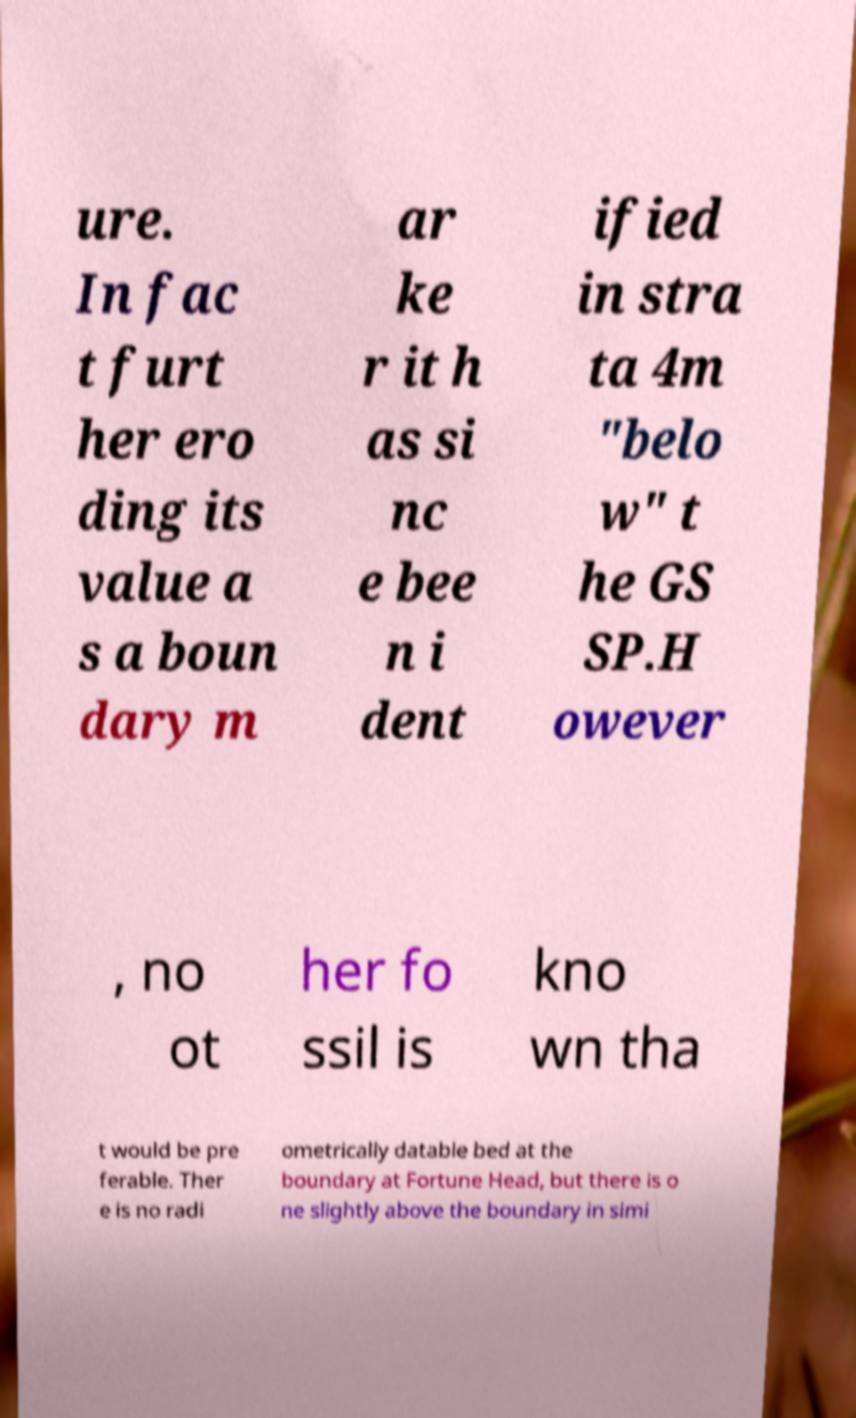Can you accurately transcribe the text from the provided image for me? ure. In fac t furt her ero ding its value a s a boun dary m ar ke r it h as si nc e bee n i dent ified in stra ta 4m "belo w" t he GS SP.H owever , no ot her fo ssil is kno wn tha t would be pre ferable. Ther e is no radi ometrically datable bed at the boundary at Fortune Head, but there is o ne slightly above the boundary in simi 